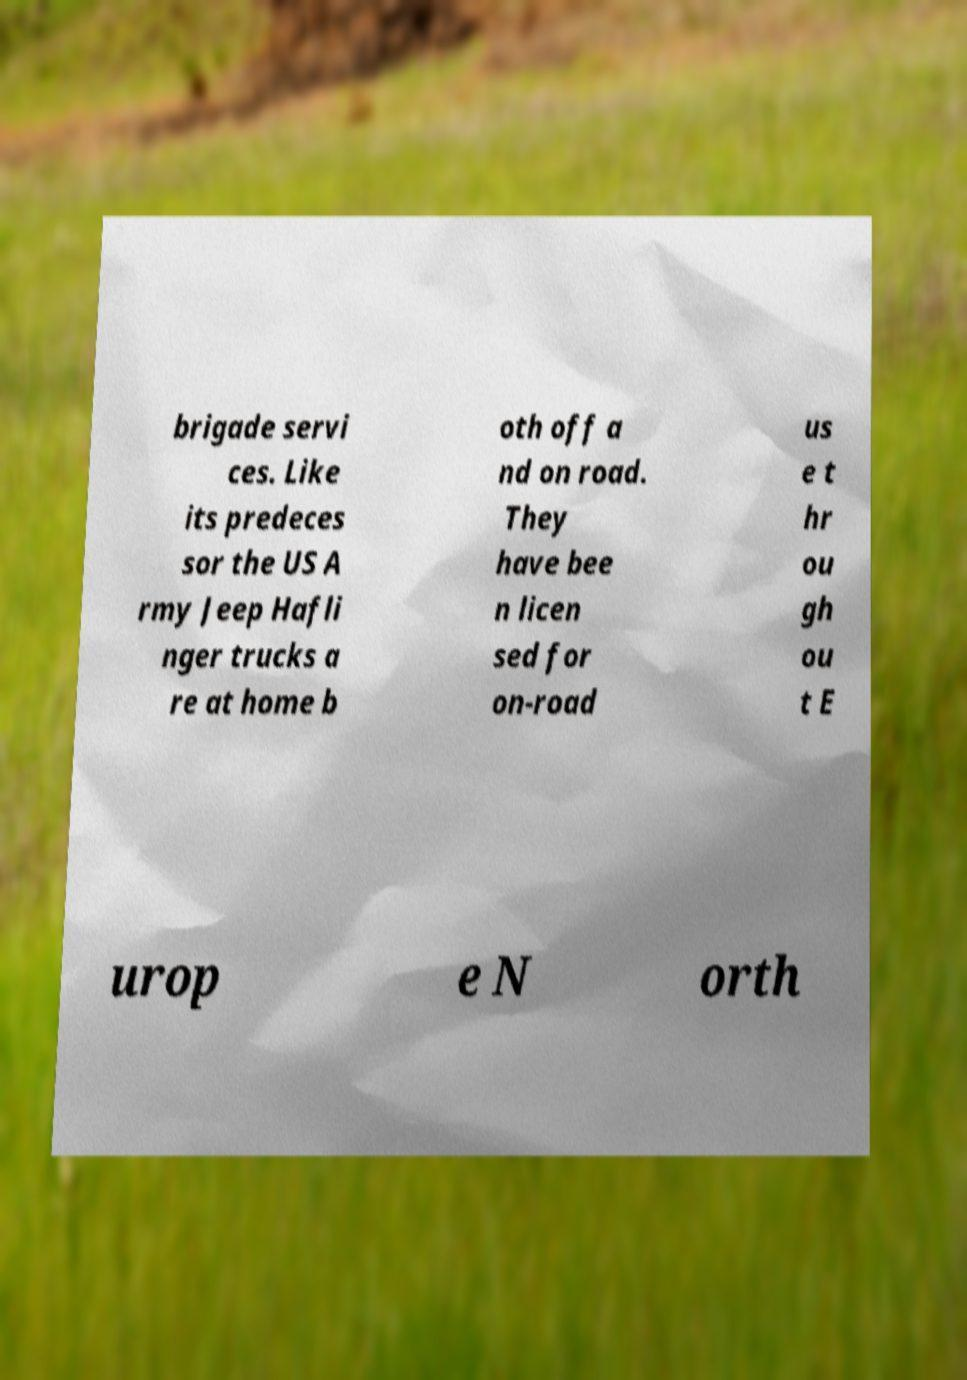What messages or text are displayed in this image? I need them in a readable, typed format. brigade servi ces. Like its predeces sor the US A rmy Jeep Hafli nger trucks a re at home b oth off a nd on road. They have bee n licen sed for on-road us e t hr ou gh ou t E urop e N orth 